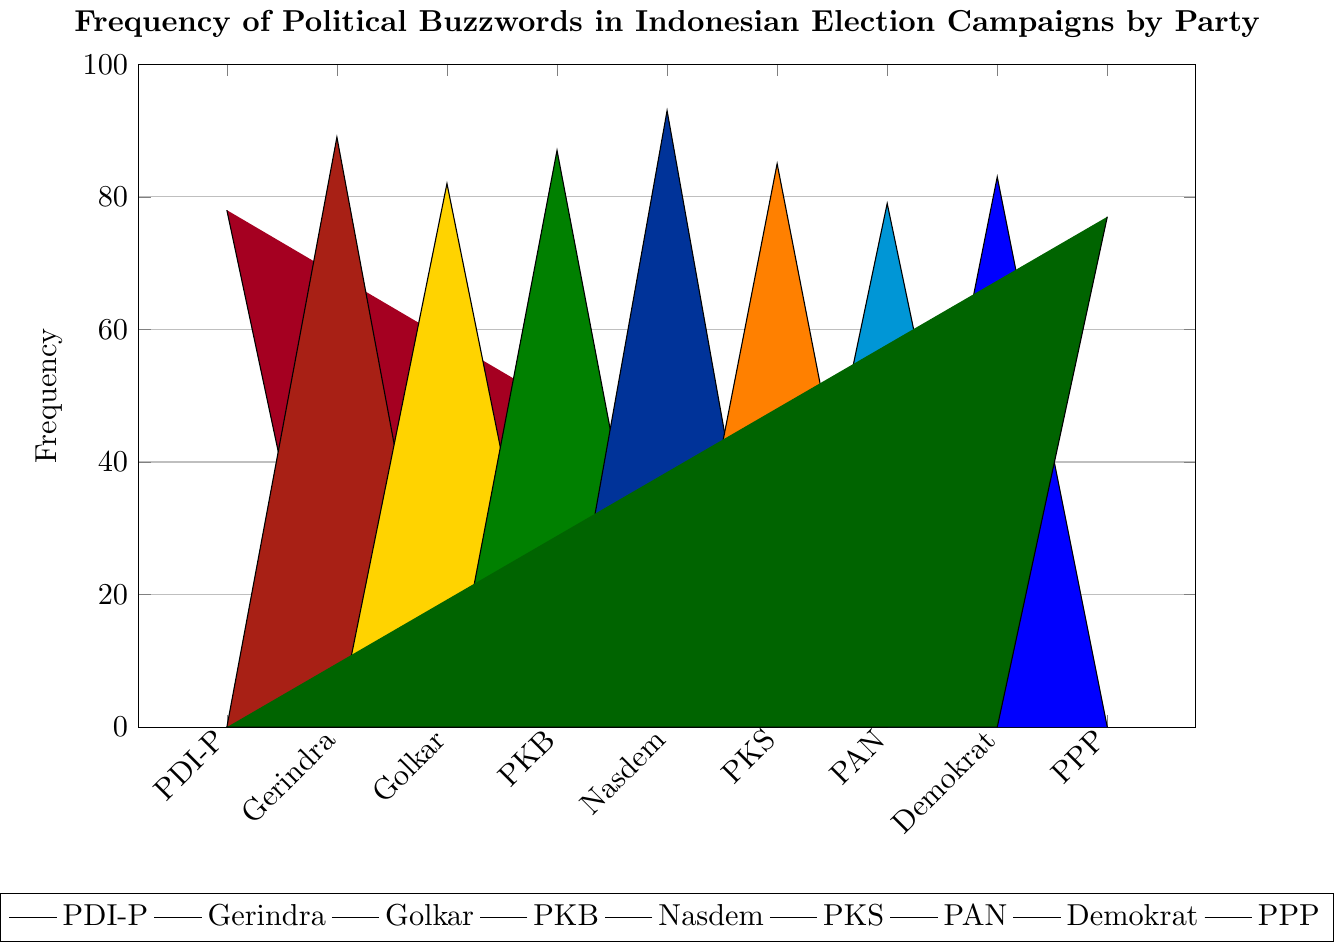What is the most frequently used buzzword by Nasdem? Nasdem's highest bar in the chart corresponds to the frequency of "Perubahan" with a height of 93.
Answer: Perubahan Which party uses the buzzword "Reformasi" the most? Gerindra has the highest frequency for "Reformasi" at 71, compared to other parties mentioning this buzzword.
Answer: Gerindra How many times is the word "Kesejahteraan" used by Golkar? The bar representing "Kesejahteraan" for Golkar shows a height of 68.
Answer: 68 Which party mentions the buzzword "Persatuan" and how frequently do they mention it? PKB mentions "Persatuan" 59 times, and PPP mentions it 56 times.
Answer: PKB: 59, PPP: 56 How does the use of "Pancasila" by PDI-P compare to the use of "Syariah" by PKS? PDI-P uses "Pancasila" 65 times, while PKS uses "Syariah" 85 times.
Answer: PKS uses "Syariah" more Compare the frequency of the buzzword "Stabilitas" by Golkar and "Keberagaman" by PKB. Golkar uses "Stabilitas" 82 times, while PKB uses "Keberagaman" 72 times.
Answer: Golkar uses "Stabilitas" more What is the sum of the frequencies of the buzzwords "Demokrasi" by Nasdem and "Integritas" by Demokrat? Nasdem uses "Demokrasi" 67 times and Demokrat uses "Integritas" 64 times. Summing these gives 67 + 64 = 131.
Answer: 131 Which party uses the buzzword "Gotong Royong," and what is its frequency? The chart shows that "Gotong Royong" is mentioned by PDI-P 78 times.
Answer: PDI-P, 78 Which party has the highest total combined frequency among the buzzwords shown in the chart? Add the frequencies of all buzzwords for each party and compare. Nasdem (93+81+67)=241, PKB (87+72+59)=218, and Gerindra (89+71+63)=223.
Answer: Nasdem What is the average frequency of the buzzwords used by Demokrat? Sum the frequencies of Demokrat's buzzwords (83 + 75 + 64 = 222) and divide by 3. So, 222 / 3 = 74.
Answer: 74 